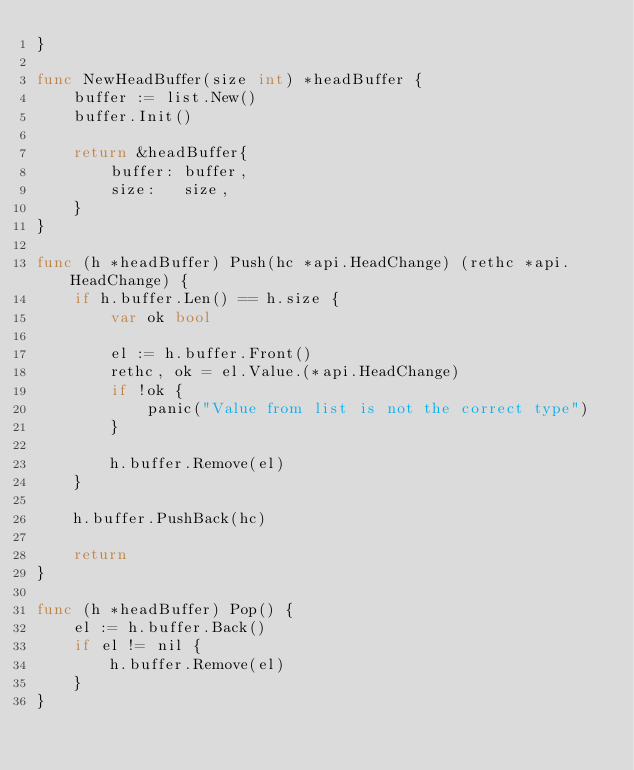Convert code to text. <code><loc_0><loc_0><loc_500><loc_500><_Go_>}

func NewHeadBuffer(size int) *headBuffer {
	buffer := list.New()
	buffer.Init()

	return &headBuffer{
		buffer: buffer,
		size:   size,
	}
}

func (h *headBuffer) Push(hc *api.HeadChange) (rethc *api.HeadChange) {
	if h.buffer.Len() == h.size {
		var ok bool

		el := h.buffer.Front()
		rethc, ok = el.Value.(*api.HeadChange)
		if !ok {
			panic("Value from list is not the correct type")
		}

		h.buffer.Remove(el)
	}

	h.buffer.PushBack(hc)

	return
}

func (h *headBuffer) Pop() {
	el := h.buffer.Back()
	if el != nil {
		h.buffer.Remove(el)
	}
}
</code> 